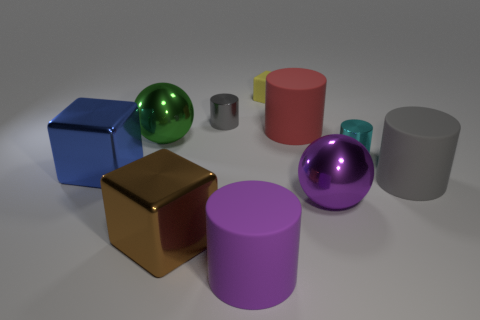Subtract all small gray cylinders. How many cylinders are left? 4 Subtract all purple cylinders. How many cylinders are left? 4 Subtract all brown cylinders. Subtract all purple balls. How many cylinders are left? 5 Subtract all spheres. How many objects are left? 8 Subtract 0 purple blocks. How many objects are left? 10 Subtract all blue metallic objects. Subtract all big purple objects. How many objects are left? 7 Add 7 gray metallic things. How many gray metallic things are left? 8 Add 6 small yellow things. How many small yellow things exist? 7 